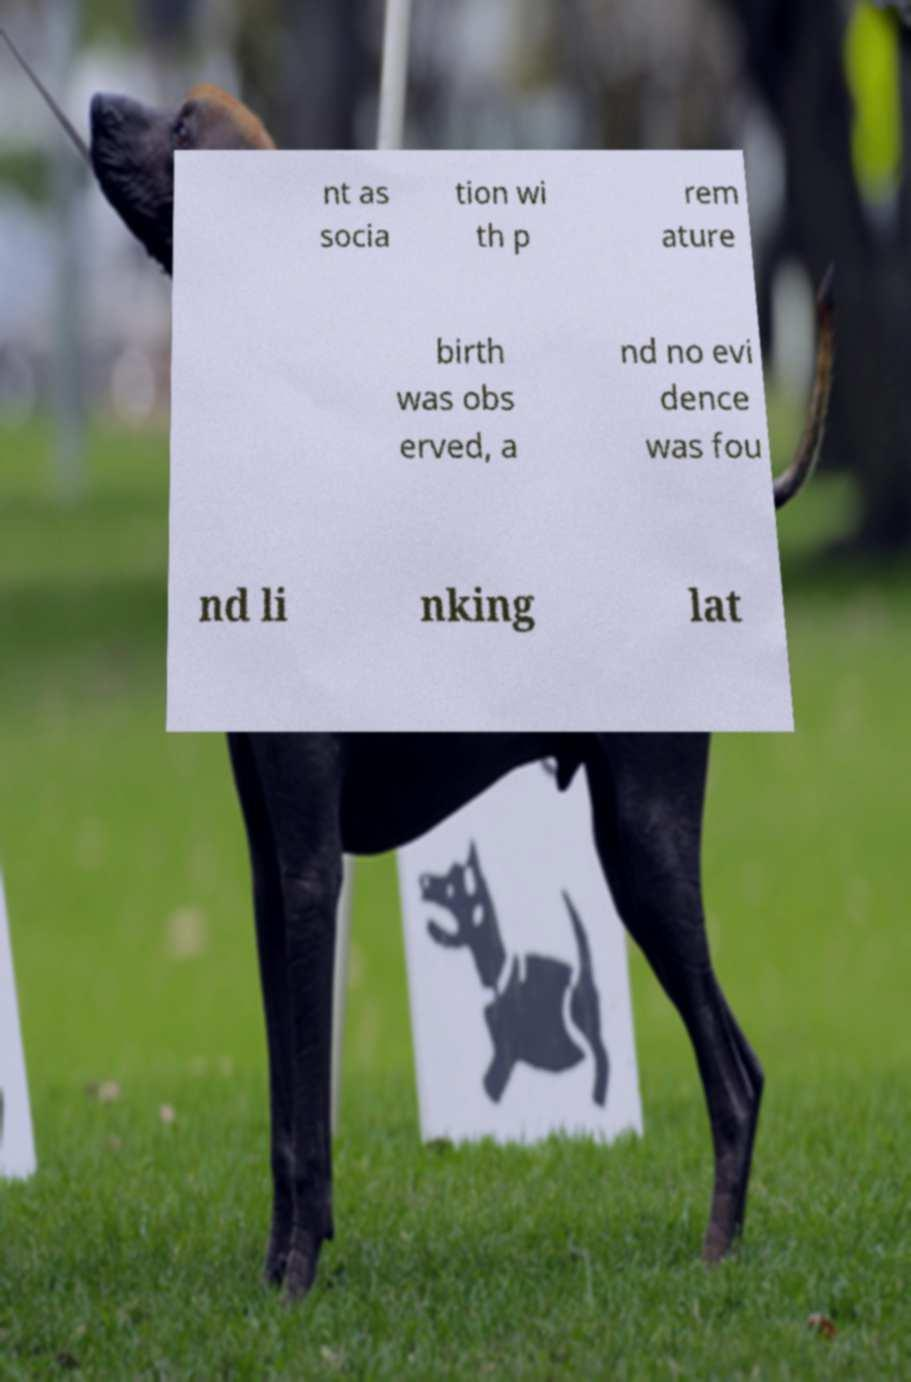What messages or text are displayed in this image? I need them in a readable, typed format. nt as socia tion wi th p rem ature birth was obs erved, a nd no evi dence was fou nd li nking lat 